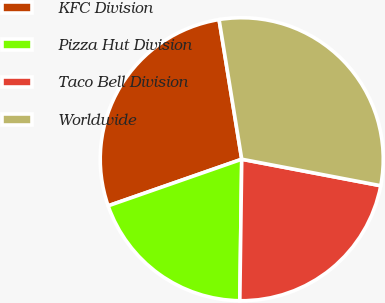Convert chart. <chart><loc_0><loc_0><loc_500><loc_500><pie_chart><fcel>KFC Division<fcel>Pizza Hut Division<fcel>Taco Bell Division<fcel>Worldwide<nl><fcel>27.78%<fcel>19.44%<fcel>22.22%<fcel>30.56%<nl></chart> 